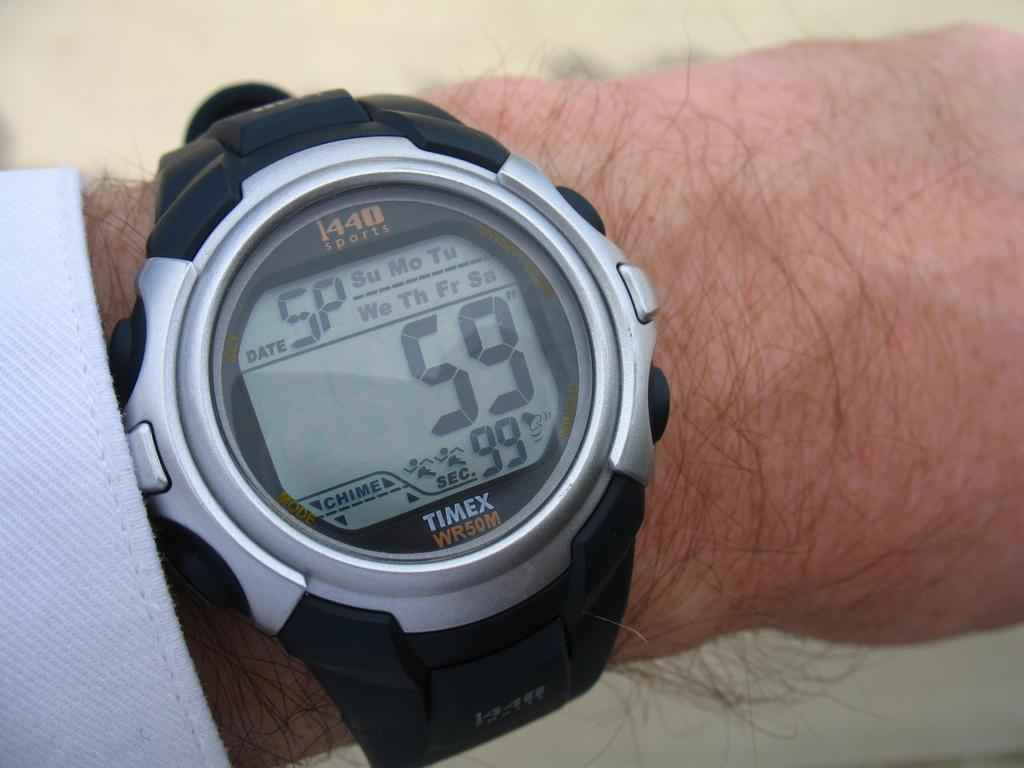<image>
Write a terse but informative summary of the picture. A man is wearing a Timex WR50M watch on his wrist. 